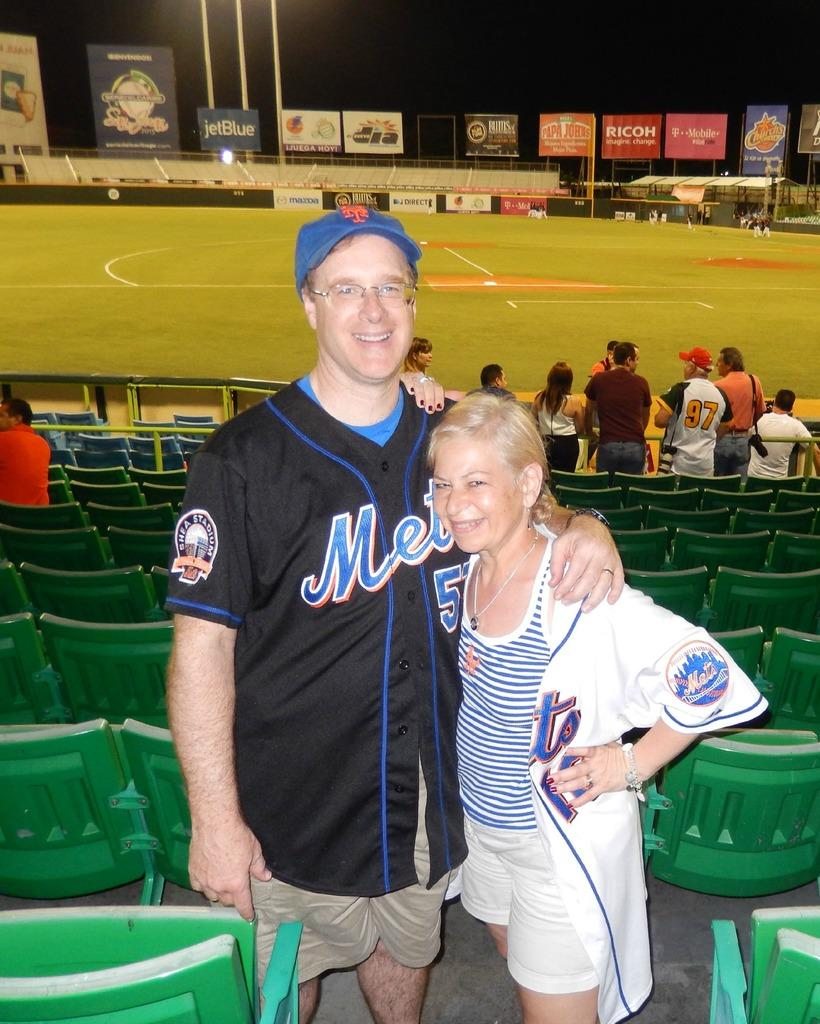<image>
Describe the image concisely. Someone at a baseball field with a black mets jersey on 